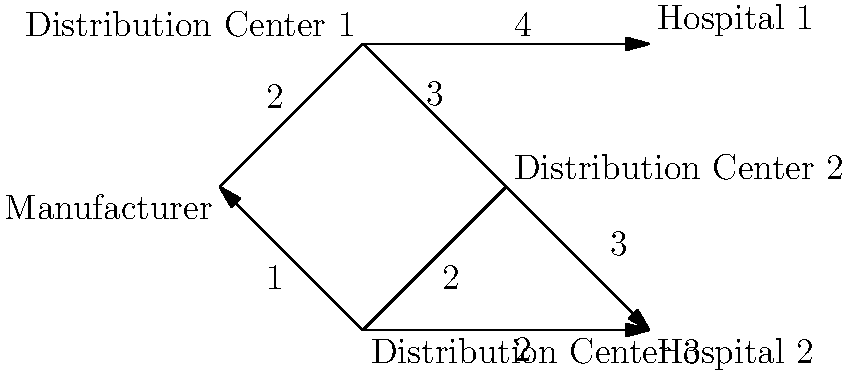Analyze the supply chain network diagram for medical equipment distribution. If a critical shipment of ventilators needs to be sent from the Manufacturer to Hospital 2, what is the minimum number of intermediary stops required, and what is the total weight of the optimal path? To solve this problem, we need to analyze all possible paths from the Manufacturer to Hospital 2 and determine the one with the minimum number of intermediary stops and the lowest total weight. Let's break it down step-by-step:

1. Identify all possible paths:
   a. Manufacturer → Distribution Center 1 → Distribution Center 2 → Hospital 2
   b. Manufacturer → Distribution Center 2 → Hospital 2
   c. Manufacturer → Distribution Center 3 → Hospital 2

2. Calculate the number of intermediary stops and total weight for each path:
   a. 2 stops, total weight = 2 + 3 + 3 = 8
   b. 1 stop, total weight = 3 + 3 = 6
   c. 1 stop, total weight = 1 + 2 = 3

3. Compare the paths:
   Path (b) and (c) both have the minimum number of intermediary stops (1).
   Among these, path (c) has the lowest total weight (3).

4. Determine the optimal path:
   The optimal path is Manufacturer → Distribution Center 3 → Hospital 2

Therefore, the minimum number of intermediary stops required is 1, and the total weight of the optimal path is 3.
Answer: 1 stop, total weight 3 